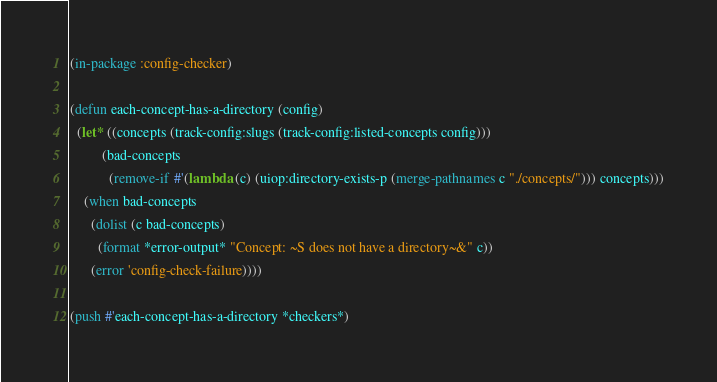<code> <loc_0><loc_0><loc_500><loc_500><_Lisp_>(in-package :config-checker)

(defun each-concept-has-a-directory (config)
  (let* ((concepts (track-config:slugs (track-config:listed-concepts config)))
         (bad-concepts
           (remove-if #'(lambda (c) (uiop:directory-exists-p (merge-pathnames c "./concepts/"))) concepts)))
    (when bad-concepts
      (dolist (c bad-concepts)
        (format *error-output* "Concept: ~S does not have a directory~&" c))
      (error 'config-check-failure))))

(push #'each-concept-has-a-directory *checkers*)
</code> 